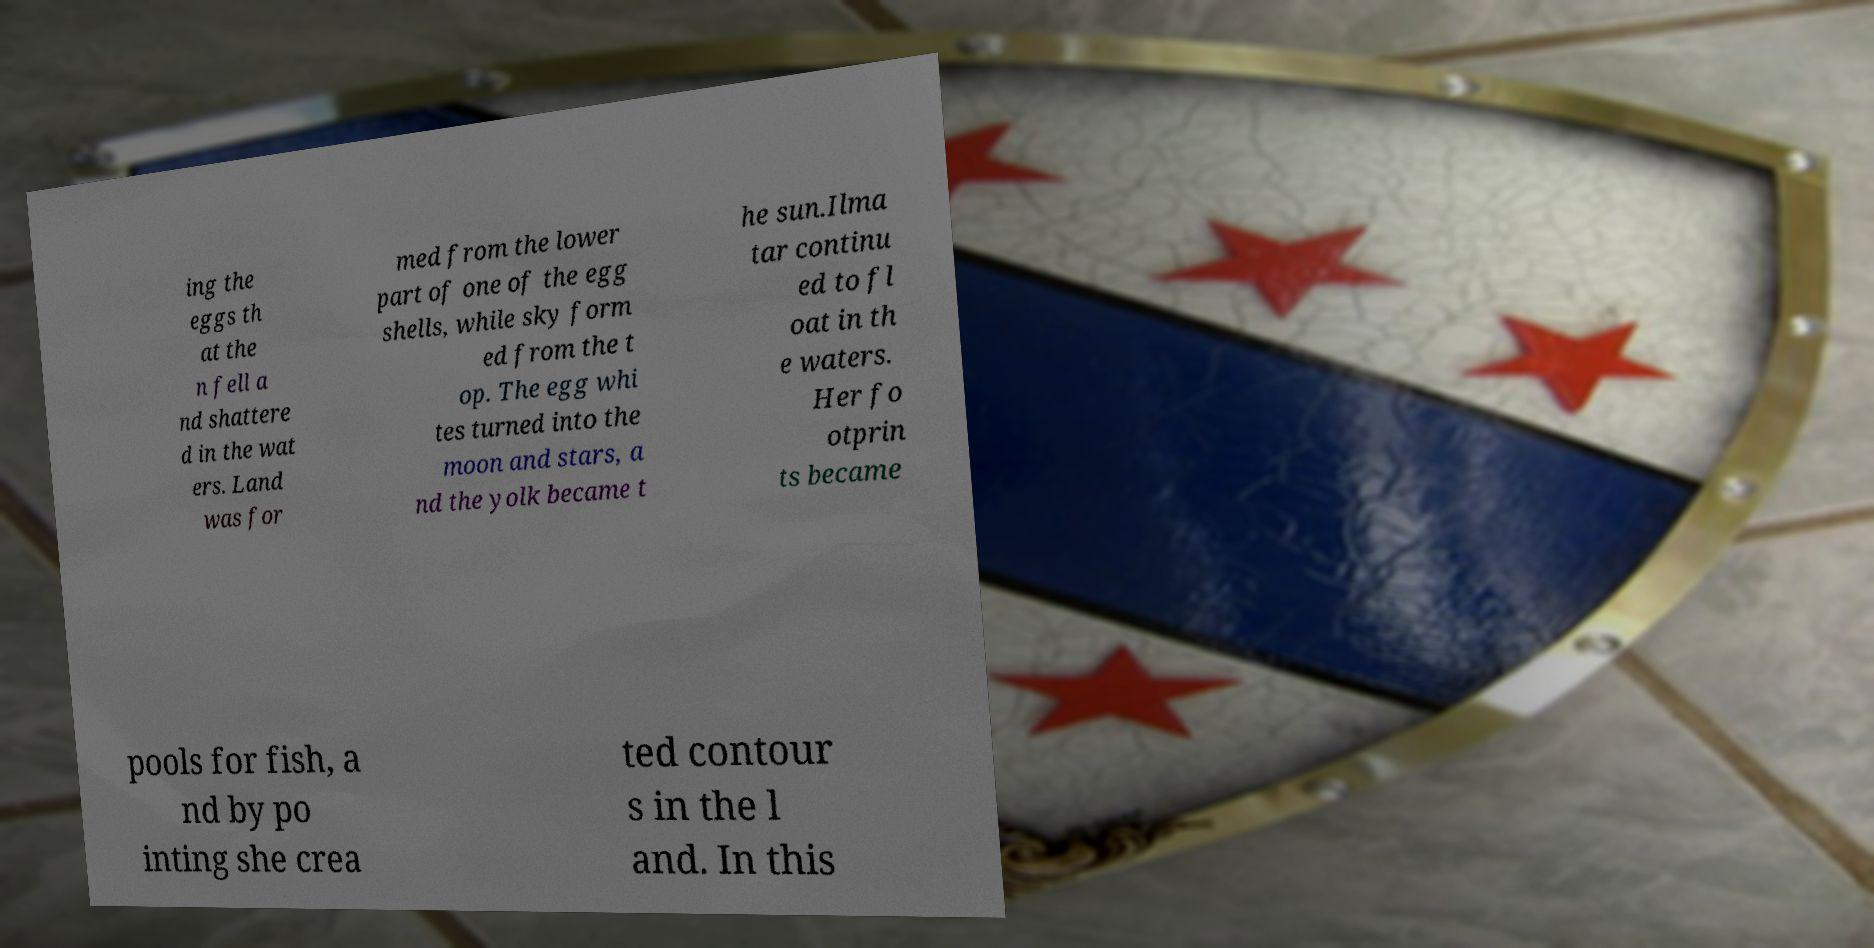Can you read and provide the text displayed in the image?This photo seems to have some interesting text. Can you extract and type it out for me? ing the eggs th at the n fell a nd shattere d in the wat ers. Land was for med from the lower part of one of the egg shells, while sky form ed from the t op. The egg whi tes turned into the moon and stars, a nd the yolk became t he sun.Ilma tar continu ed to fl oat in th e waters. Her fo otprin ts became pools for fish, a nd by po inting she crea ted contour s in the l and. In this 